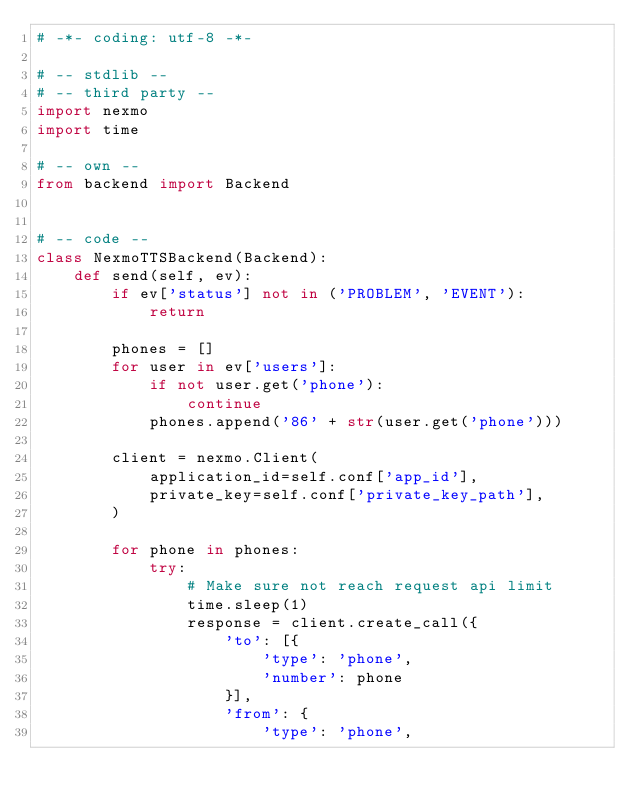<code> <loc_0><loc_0><loc_500><loc_500><_Python_># -*- coding: utf-8 -*-

# -- stdlib --
# -- third party --
import nexmo
import time

# -- own --
from backend import Backend


# -- code --
class NexmoTTSBackend(Backend):
    def send(self, ev):
        if ev['status'] not in ('PROBLEM', 'EVENT'):
            return

        phones = []
        for user in ev['users']:
            if not user.get('phone'):
                continue
            phones.append('86' + str(user.get('phone')))

        client = nexmo.Client(
            application_id=self.conf['app_id'],
            private_key=self.conf['private_key_path'],
        )

        for phone in phones:
            try:
                # Make sure not reach request api limit
                time.sleep(1)
                response = client.create_call({
                    'to': [{
                        'type': 'phone',
                        'number': phone
                    }],
                    'from': {
                        'type': 'phone',</code> 